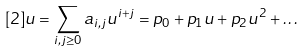Convert formula to latex. <formula><loc_0><loc_0><loc_500><loc_500>[ 2 ] u = \sum _ { i , j \geq 0 } a _ { i , j } u ^ { i + j } = p _ { 0 } + p _ { 1 } u + p _ { 2 } u ^ { 2 } + \dots</formula> 